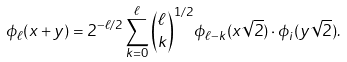Convert formula to latex. <formula><loc_0><loc_0><loc_500><loc_500>\phi _ { \ell } ( x + y ) = 2 ^ { - \ell / 2 } \sum ^ { \ell } _ { k = 0 } \binom { \ell } { k } ^ { 1 / 2 } \phi _ { \ell - k } ( x \sqrt { 2 } ) \cdot \phi _ { i } ( y \sqrt { 2 } ) .</formula> 